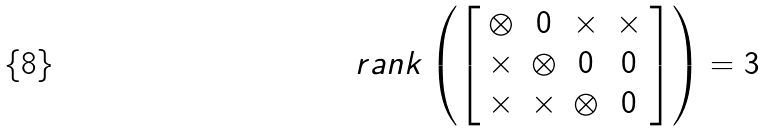Convert formula to latex. <formula><loc_0><loc_0><loc_500><loc_500>r a n k \left ( \left [ \begin{array} { c c c c } \otimes & 0 & \times & \times \\ \times & \otimes & 0 & 0 \\ \times & \times & \otimes & 0 \end{array} \right ] \right ) = 3</formula> 